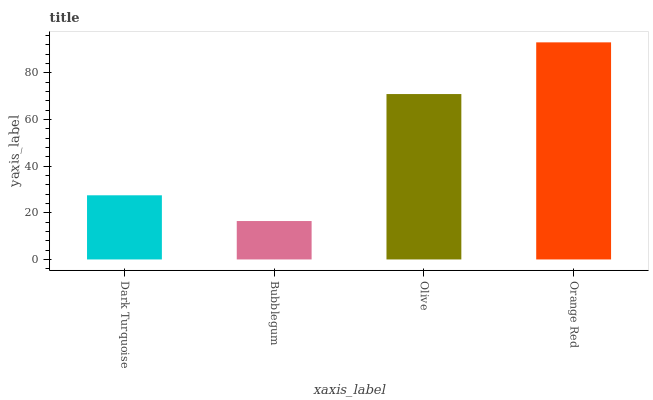Is Bubblegum the minimum?
Answer yes or no. Yes. Is Orange Red the maximum?
Answer yes or no. Yes. Is Olive the minimum?
Answer yes or no. No. Is Olive the maximum?
Answer yes or no. No. Is Olive greater than Bubblegum?
Answer yes or no. Yes. Is Bubblegum less than Olive?
Answer yes or no. Yes. Is Bubblegum greater than Olive?
Answer yes or no. No. Is Olive less than Bubblegum?
Answer yes or no. No. Is Olive the high median?
Answer yes or no. Yes. Is Dark Turquoise the low median?
Answer yes or no. Yes. Is Dark Turquoise the high median?
Answer yes or no. No. Is Bubblegum the low median?
Answer yes or no. No. 